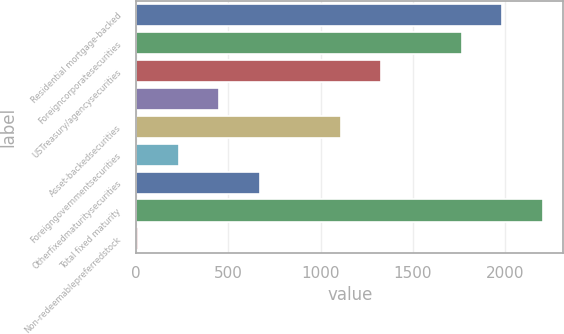Convert chart to OTSL. <chart><loc_0><loc_0><loc_500><loc_500><bar_chart><fcel>Residential mortgage-backed<fcel>Foreigncorporatesecurities<fcel>USTreasury/agencysecurities<fcel>Unnamed: 3<fcel>Asset-backedsecurities<fcel>Foreigngovernmentsecurities<fcel>Otherfixedmaturitysecurities<fcel>Total fixed maturity<fcel>Non-redeemablepreferredstock<nl><fcel>1985.6<fcel>1766.2<fcel>1327.4<fcel>449.8<fcel>1108<fcel>230.4<fcel>669.2<fcel>2205<fcel>11<nl></chart> 